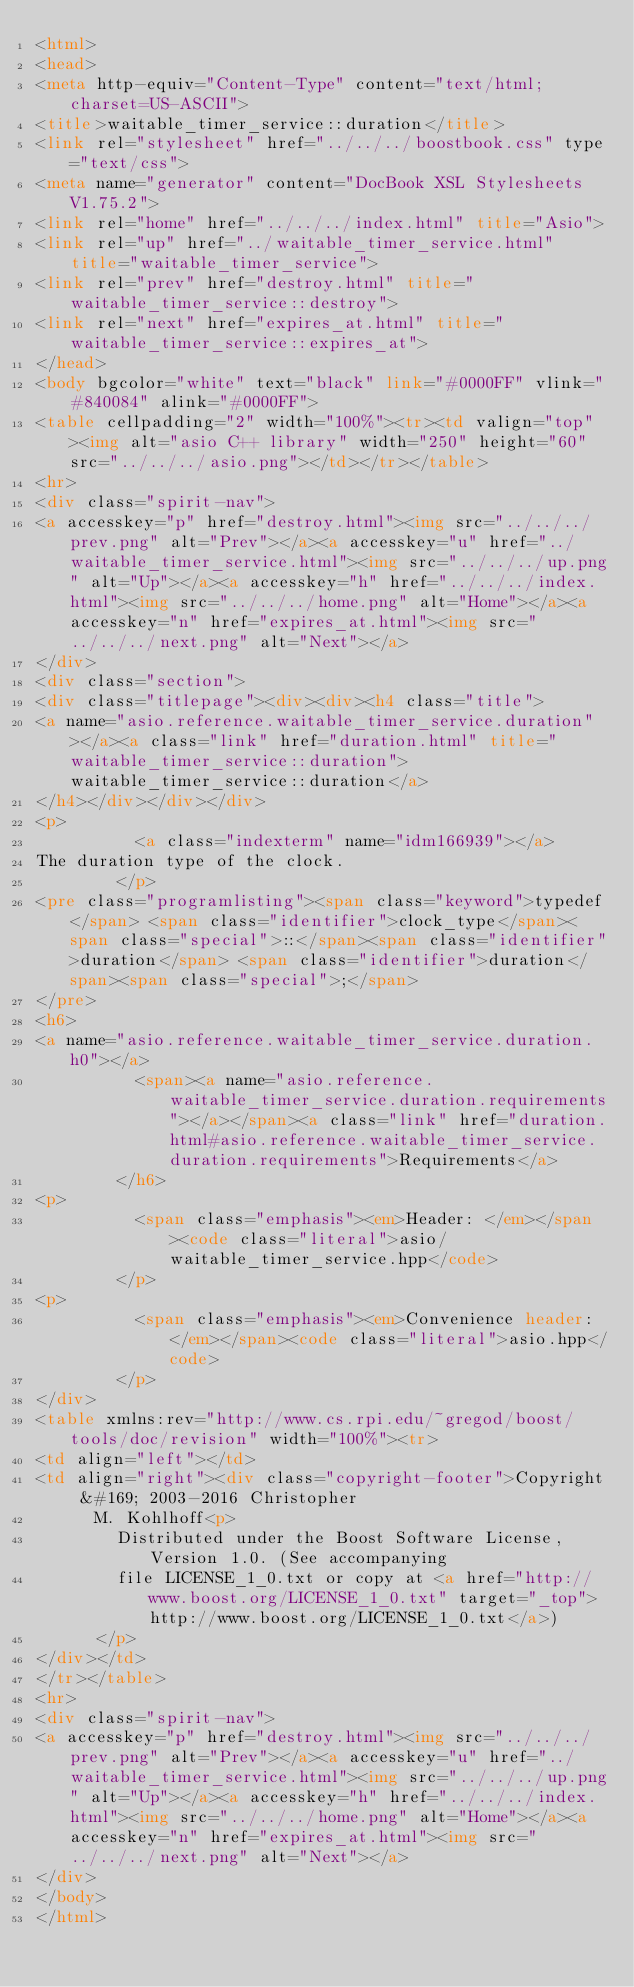Convert code to text. <code><loc_0><loc_0><loc_500><loc_500><_HTML_><html>
<head>
<meta http-equiv="Content-Type" content="text/html; charset=US-ASCII">
<title>waitable_timer_service::duration</title>
<link rel="stylesheet" href="../../../boostbook.css" type="text/css">
<meta name="generator" content="DocBook XSL Stylesheets V1.75.2">
<link rel="home" href="../../../index.html" title="Asio">
<link rel="up" href="../waitable_timer_service.html" title="waitable_timer_service">
<link rel="prev" href="destroy.html" title="waitable_timer_service::destroy">
<link rel="next" href="expires_at.html" title="waitable_timer_service::expires_at">
</head>
<body bgcolor="white" text="black" link="#0000FF" vlink="#840084" alink="#0000FF">
<table cellpadding="2" width="100%"><tr><td valign="top"><img alt="asio C++ library" width="250" height="60" src="../../../asio.png"></td></tr></table>
<hr>
<div class="spirit-nav">
<a accesskey="p" href="destroy.html"><img src="../../../prev.png" alt="Prev"></a><a accesskey="u" href="../waitable_timer_service.html"><img src="../../../up.png" alt="Up"></a><a accesskey="h" href="../../../index.html"><img src="../../../home.png" alt="Home"></a><a accesskey="n" href="expires_at.html"><img src="../../../next.png" alt="Next"></a>
</div>
<div class="section">
<div class="titlepage"><div><div><h4 class="title">
<a name="asio.reference.waitable_timer_service.duration"></a><a class="link" href="duration.html" title="waitable_timer_service::duration">waitable_timer_service::duration</a>
</h4></div></div></div>
<p>
          <a class="indexterm" name="idm166939"></a> 
The duration type of the clock.
        </p>
<pre class="programlisting"><span class="keyword">typedef</span> <span class="identifier">clock_type</span><span class="special">::</span><span class="identifier">duration</span> <span class="identifier">duration</span><span class="special">;</span>
</pre>
<h6>
<a name="asio.reference.waitable_timer_service.duration.h0"></a>
          <span><a name="asio.reference.waitable_timer_service.duration.requirements"></a></span><a class="link" href="duration.html#asio.reference.waitable_timer_service.duration.requirements">Requirements</a>
        </h6>
<p>
          <span class="emphasis"><em>Header: </em></span><code class="literal">asio/waitable_timer_service.hpp</code>
        </p>
<p>
          <span class="emphasis"><em>Convenience header: </em></span><code class="literal">asio.hpp</code>
        </p>
</div>
<table xmlns:rev="http://www.cs.rpi.edu/~gregod/boost/tools/doc/revision" width="100%"><tr>
<td align="left"></td>
<td align="right"><div class="copyright-footer">Copyright &#169; 2003-2016 Christopher
      M. Kohlhoff<p>
        Distributed under the Boost Software License, Version 1.0. (See accompanying
        file LICENSE_1_0.txt or copy at <a href="http://www.boost.org/LICENSE_1_0.txt" target="_top">http://www.boost.org/LICENSE_1_0.txt</a>)
      </p>
</div></td>
</tr></table>
<hr>
<div class="spirit-nav">
<a accesskey="p" href="destroy.html"><img src="../../../prev.png" alt="Prev"></a><a accesskey="u" href="../waitable_timer_service.html"><img src="../../../up.png" alt="Up"></a><a accesskey="h" href="../../../index.html"><img src="../../../home.png" alt="Home"></a><a accesskey="n" href="expires_at.html"><img src="../../../next.png" alt="Next"></a>
</div>
</body>
</html>
</code> 